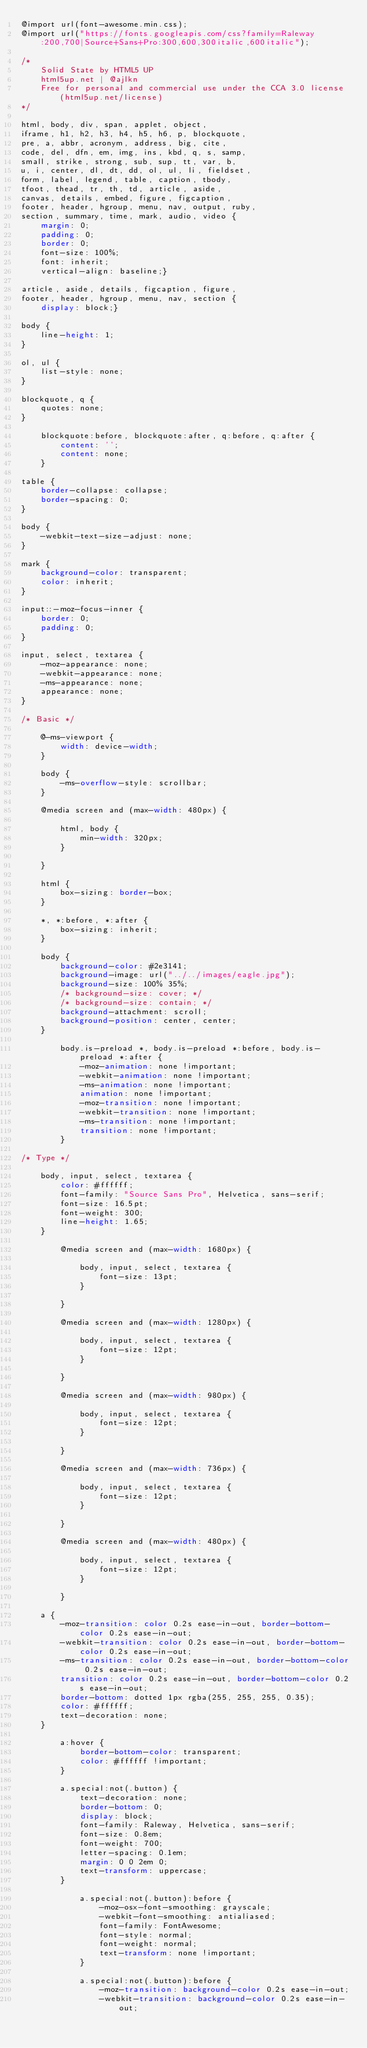Convert code to text. <code><loc_0><loc_0><loc_500><loc_500><_CSS_>@import url(font-awesome.min.css);
@import url("https://fonts.googleapis.com/css?family=Raleway:200,700|Source+Sans+Pro:300,600,300italic,600italic");

/*
	Solid State by HTML5 UP
	html5up.net | @ajlkn
	Free for personal and commercial use under the CCA 3.0 license (html5up.net/license)
*/

html, body, div, span, applet, object,
iframe, h1, h2, h3, h4, h5, h6, p, blockquote,
pre, a, abbr, acronym, address, big, cite,
code, del, dfn, em, img, ins, kbd, q, s, samp,
small, strike, strong, sub, sup, tt, var, b,
u, i, center, dl, dt, dd, ol, ul, li, fieldset,
form, label, legend, table, caption, tbody,
tfoot, thead, tr, th, td, article, aside,
canvas, details, embed, figure, figcaption,
footer, header, hgroup, menu, nav, output, ruby,
section, summary, time, mark, audio, video {
	margin: 0;
	padding: 0;
	border: 0;
	font-size: 100%;
	font: inherit;
	vertical-align: baseline;}

article, aside, details, figcaption, figure,
footer, header, hgroup, menu, nav, section {
	display: block;}

body {
	line-height: 1;
}

ol, ul {
	list-style: none;
}

blockquote, q {
	quotes: none;
}

	blockquote:before, blockquote:after, q:before, q:after {
		content: '';
		content: none;
	}

table {
	border-collapse: collapse;
	border-spacing: 0;
}

body {
	-webkit-text-size-adjust: none;
}

mark {
	background-color: transparent;
	color: inherit;
}

input::-moz-focus-inner {
	border: 0;
	padding: 0;
}

input, select, textarea {
	-moz-appearance: none;
	-webkit-appearance: none;
	-ms-appearance: none;
	appearance: none;
}

/* Basic */

	@-ms-viewport {
		width: device-width;
	}

	body {
		-ms-overflow-style: scrollbar;
	}

	@media screen and (max-width: 480px) {

		html, body {
			min-width: 320px;
		}

	}

	html {
		box-sizing: border-box;
	}

	*, *:before, *:after {
		box-sizing: inherit;
	}

	body {
		background-color: #2e3141;
		background-image: url("../../images/eagle.jpg");
		background-size: 100% 35%;
		/* background-size: cover; */
		/* background-size: contain; */
		background-attachment: scroll;
		background-position: center, center;
	}

		body.is-preload *, body.is-preload *:before, body.is-preload *:after {
			-moz-animation: none !important;
			-webkit-animation: none !important;
			-ms-animation: none !important;
			animation: none !important;
			-moz-transition: none !important;
			-webkit-transition: none !important;
			-ms-transition: none !important;
			transition: none !important;
		}

/* Type */

	body, input, select, textarea {
		color: #ffffff;
		font-family: "Source Sans Pro", Helvetica, sans-serif;
		font-size: 16.5pt;
		font-weight: 300;
		line-height: 1.65;
	}

		@media screen and (max-width: 1680px) {

			body, input, select, textarea {
				font-size: 13pt;
			}

		}

		@media screen and (max-width: 1280px) {

			body, input, select, textarea {
				font-size: 12pt;
			}

		}

		@media screen and (max-width: 980px) {

			body, input, select, textarea {
				font-size: 12pt;
			}

		}

		@media screen and (max-width: 736px) {

			body, input, select, textarea {
				font-size: 12pt;
			}

		}

		@media screen and (max-width: 480px) {

			body, input, select, textarea {
				font-size: 12pt;
			}

		}

	a {
		-moz-transition: color 0.2s ease-in-out, border-bottom-color 0.2s ease-in-out;
		-webkit-transition: color 0.2s ease-in-out, border-bottom-color 0.2s ease-in-out;
		-ms-transition: color 0.2s ease-in-out, border-bottom-color 0.2s ease-in-out;
		transition: color 0.2s ease-in-out, border-bottom-color 0.2s ease-in-out;
		border-bottom: dotted 1px rgba(255, 255, 255, 0.35);
		color: #ffffff;
		text-decoration: none;
	}

		a:hover {
			border-bottom-color: transparent;
			color: #ffffff !important;
		}

		a.special:not(.button) {
			text-decoration: none;
			border-bottom: 0;
			display: block;
			font-family: Raleway, Helvetica, sans-serif;
			font-size: 0.8em;
			font-weight: 700;
			letter-spacing: 0.1em;
			margin: 0 0 2em 0;
			text-transform: uppercase;
		}

			a.special:not(.button):before {
				-moz-osx-font-smoothing: grayscale;
				-webkit-font-smoothing: antialiased;
				font-family: FontAwesome;
				font-style: normal;
				font-weight: normal;
				text-transform: none !important;
			}

			a.special:not(.button):before {
				-moz-transition: background-color 0.2s ease-in-out;
				-webkit-transition: background-color 0.2s ease-in-out;</code> 